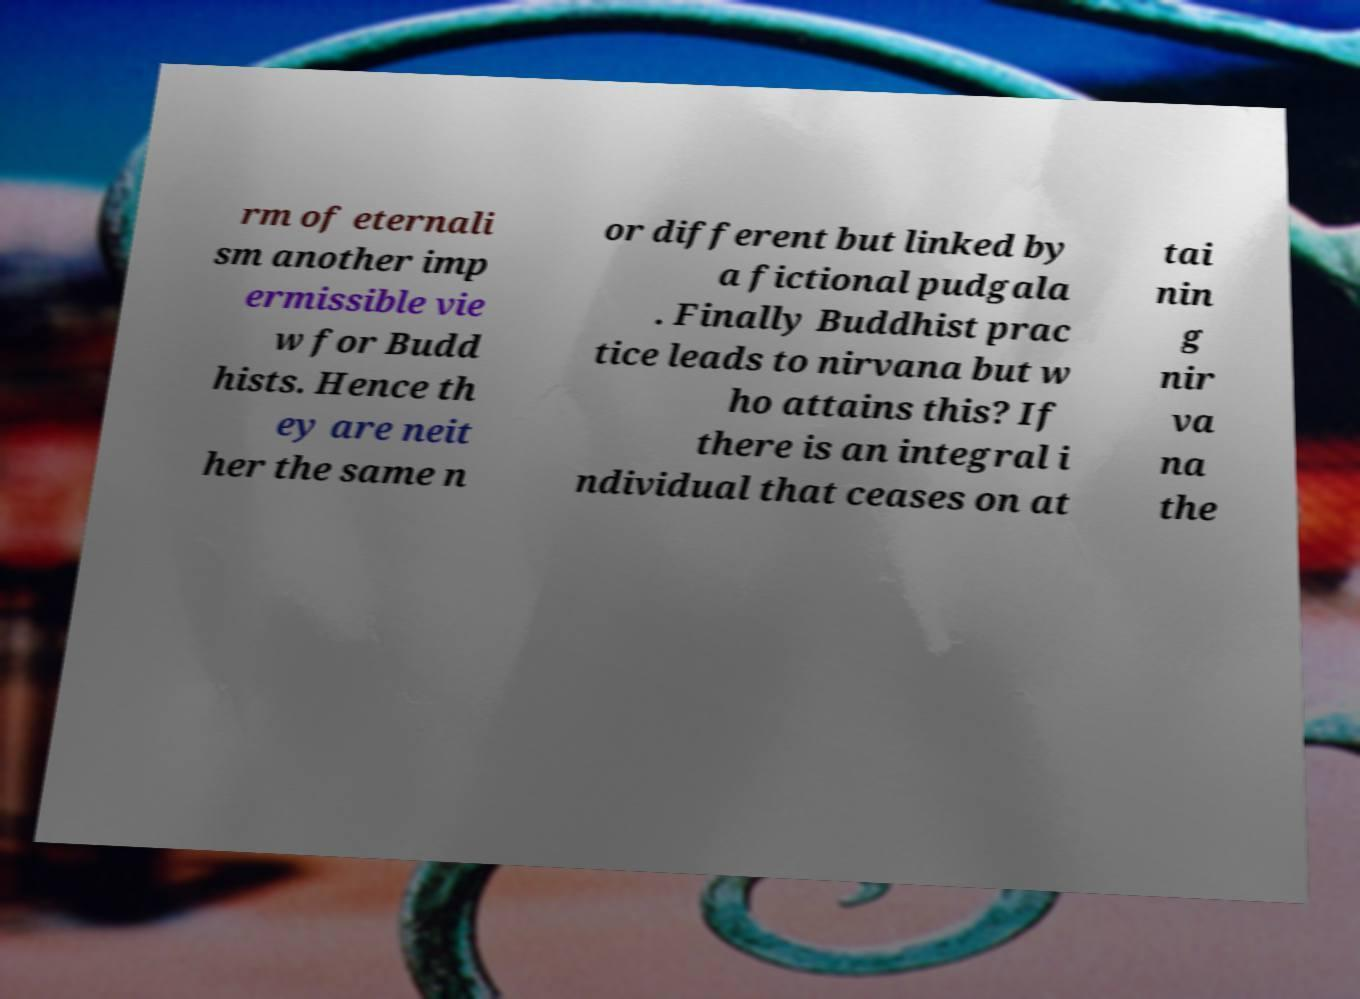For documentation purposes, I need the text within this image transcribed. Could you provide that? rm of eternali sm another imp ermissible vie w for Budd hists. Hence th ey are neit her the same n or different but linked by a fictional pudgala . Finally Buddhist prac tice leads to nirvana but w ho attains this? If there is an integral i ndividual that ceases on at tai nin g nir va na the 